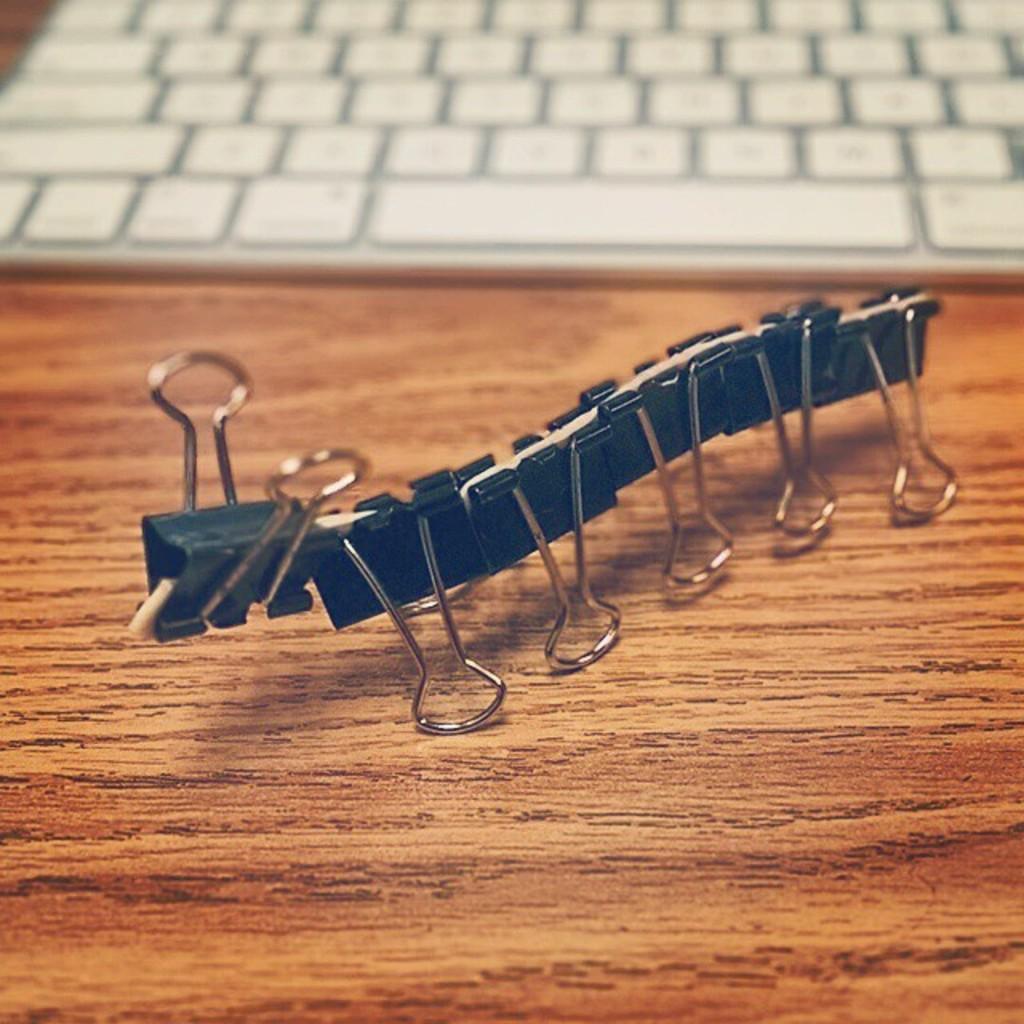Can you describe this image briefly? In this picture I can see a keyboard and few paper clips on the table. 